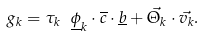<formula> <loc_0><loc_0><loc_500><loc_500>g _ { k } = \tau _ { k } \ \underline { \phi } _ { k } \cdot \overline { c } \cdot \underline { b } + \vec { \Theta _ { k } } \cdot \vec { v _ { k } } .</formula> 